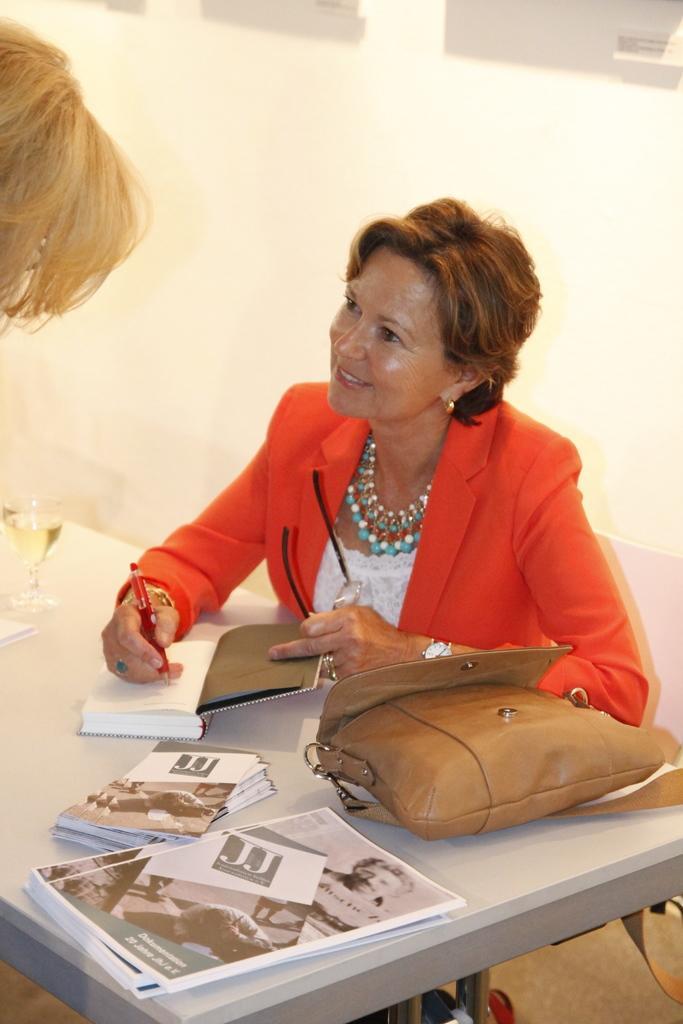In one or two sentences, can you explain what this image depicts? In this picture we can see a woman sitting on chair holding pen with her hand and writing on book and she is smiling and on table we have bag, cards and in front of her person standing and in the background we can see wall.. 